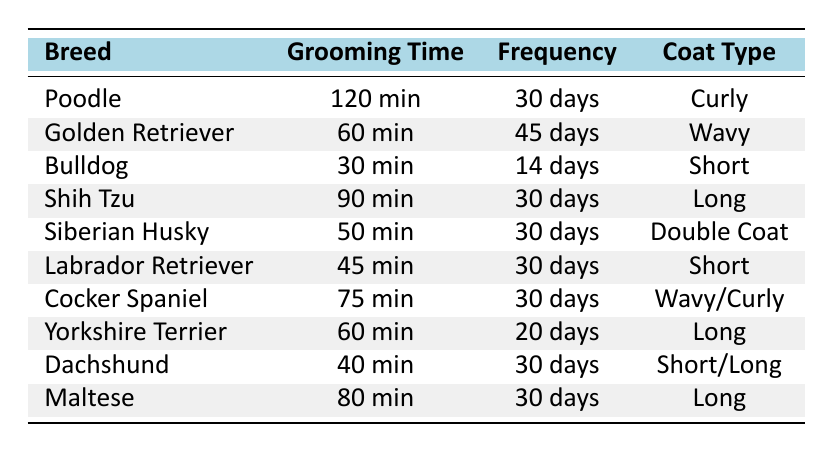What is the grooming time for a Poodle? The table lists the grooming time for a Poodle as 120 minutes.
Answer: 120 minutes How frequently should a Bulldog be groomed? According to the table, Bulldogs need grooming every 14 days.
Answer: 14 days What coat type does a Cocker Spaniel have? The table indicates that Cocker Spaniels have a Wavy/Curly coat type.
Answer: Wavy/Curly Which dog breed has the longest grooming time? By examining the grooming times, the Poodle with 120 minutes has the longest grooming time.
Answer: Poodle What is the average grooming time for dogs with a Long coat? The grooming times for Long coat dogs (Shih Tzu, Yorkshire Terrier, Maltese) are 90, 60, and 80 minutes respectively. The sum is 90 + 60 + 80 = 230 minutes. Dividing by 3, the average grooming time is 230/3 = 76.67 minutes.
Answer: 76.67 minutes Is the grooming frequency for a Yorkshire Terrier greater than that for a Labrador Retriever? Yorkshire Terrier grooming frequency is 20 days, while Labrador Retriever grooming frequency is 30 days. Since 20 is not greater than 30, the answer is no.
Answer: No How many total grooming minutes are required to groom all the dogs listed in the table? Summing all grooming times: 120 + 60 + 30 + 90 + 50 + 45 + 75 + 60 + 40 + 80 gives a total of 750 minutes.
Answer: 750 minutes Which breed requires grooming less frequently than a Cocker Spaniel? Cocker Spaniel is groomed every 30 days; the Bulldog, which is groomed every 14 days, requires less frequent grooming than that. The only other option in the table is the Labrador Retriever, which is also groomed every 30 days. Therefore, the Bulldog is the only breed that fits this description.
Answer: Bulldog Which groomed breed has the shortest grooming time? The Bulldog has the shortest grooming time at 30 minutes as reflected in the table.
Answer: Bulldog What is the difference in grooming time between a Shih Tzu and a Labrador Retriever? Shih Tzu's grooming time is 90 minutes, whereas the Labrador Retriever's is 45 minutes. The difference is 90 - 45 = 45 minutes.
Answer: 45 minutes 